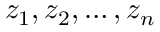Convert formula to latex. <formula><loc_0><loc_0><loc_500><loc_500>z _ { 1 } , z _ { 2 } , \dots , z _ { n }</formula> 